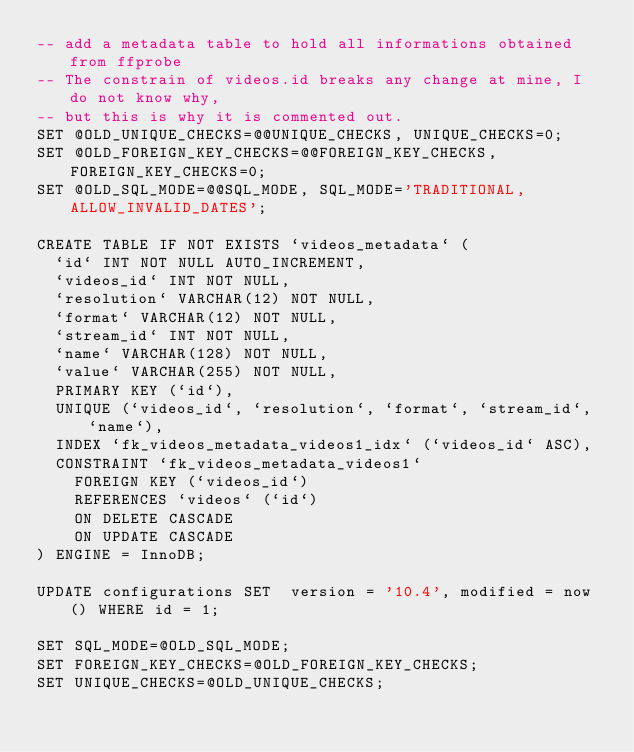Convert code to text. <code><loc_0><loc_0><loc_500><loc_500><_SQL_>-- add a metadata table to hold all informations obtained from ffprobe
-- The constrain of videos.id breaks any change at mine, I do not know why,
-- but this is why it is commented out.
SET @OLD_UNIQUE_CHECKS=@@UNIQUE_CHECKS, UNIQUE_CHECKS=0;
SET @OLD_FOREIGN_KEY_CHECKS=@@FOREIGN_KEY_CHECKS, FOREIGN_KEY_CHECKS=0;
SET @OLD_SQL_MODE=@@SQL_MODE, SQL_MODE='TRADITIONAL,ALLOW_INVALID_DATES';

CREATE TABLE IF NOT EXISTS `videos_metadata` (
  `id` INT NOT NULL AUTO_INCREMENT,
  `videos_id` INT NOT NULL,
  `resolution` VARCHAR(12) NOT NULL,
  `format` VARCHAR(12) NOT NULL,
  `stream_id` INT NOT NULL,
  `name` VARCHAR(128) NOT NULL,
  `value` VARCHAR(255) NOT NULL,
  PRIMARY KEY (`id`),
  UNIQUE (`videos_id`, `resolution`, `format`, `stream_id`, `name`),
  INDEX `fk_videos_metadata_videos1_idx` (`videos_id` ASC),
  CONSTRAINT `fk_videos_metadata_videos1`
    FOREIGN KEY (`videos_id`)
    REFERENCES `videos` (`id`)
    ON DELETE CASCADE
    ON UPDATE CASCADE
) ENGINE = InnoDB;

UPDATE configurations SET  version = '10.4', modified = now() WHERE id = 1;

SET SQL_MODE=@OLD_SQL_MODE;
SET FOREIGN_KEY_CHECKS=@OLD_FOREIGN_KEY_CHECKS;
SET UNIQUE_CHECKS=@OLD_UNIQUE_CHECKS;</code> 